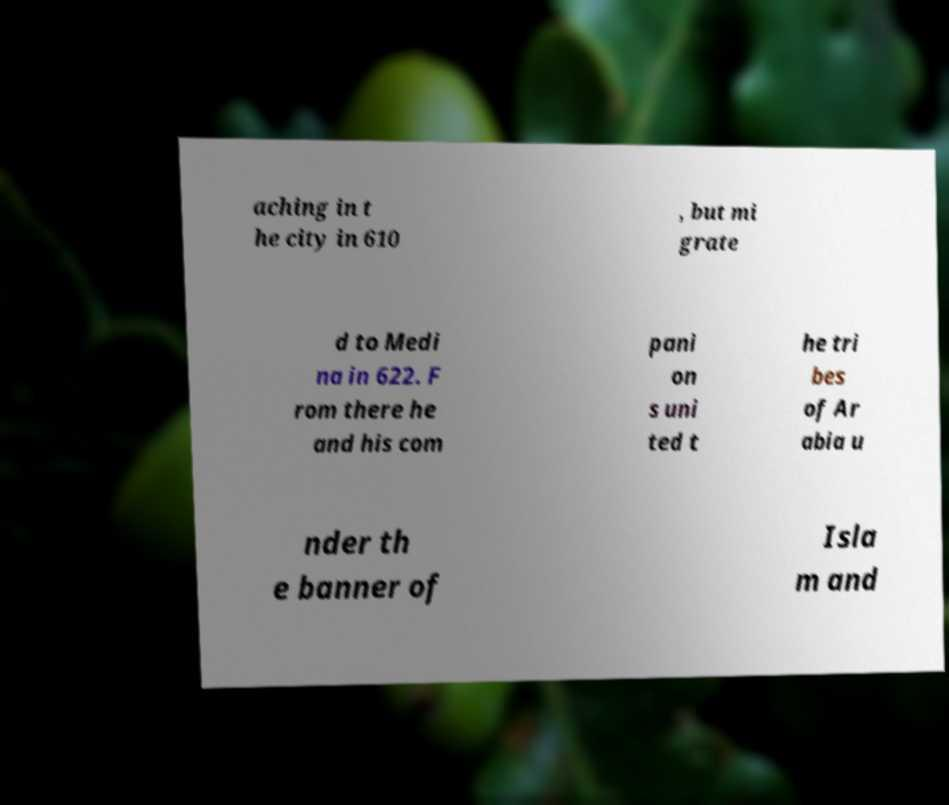Can you read and provide the text displayed in the image?This photo seems to have some interesting text. Can you extract and type it out for me? aching in t he city in 610 , but mi grate d to Medi na in 622. F rom there he and his com pani on s uni ted t he tri bes of Ar abia u nder th e banner of Isla m and 